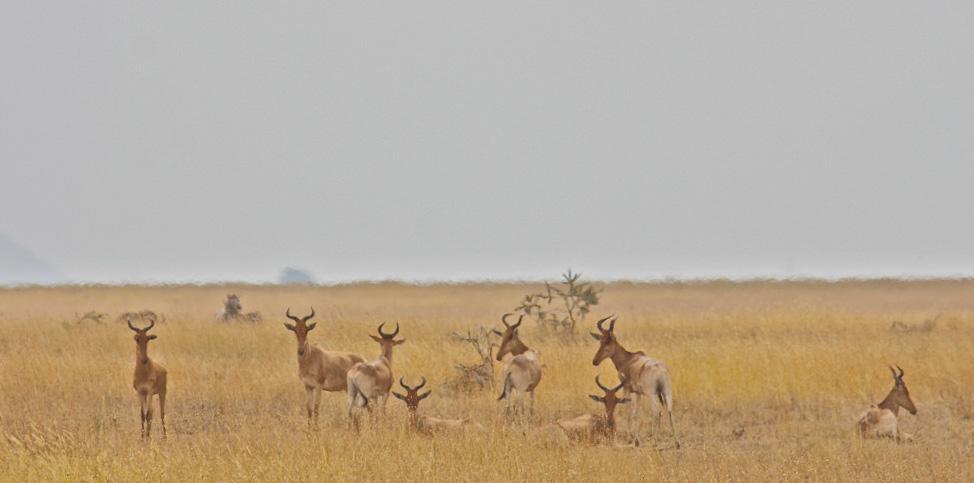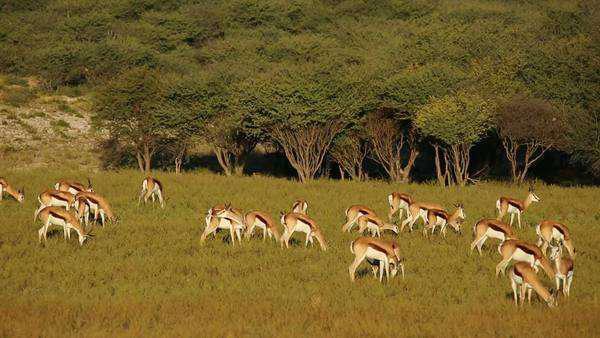The first image is the image on the left, the second image is the image on the right. For the images shown, is this caption "An image shows multiple similarly-posed gazelles with dark diagonal stripes across their bodies." true? Answer yes or no. Yes. 